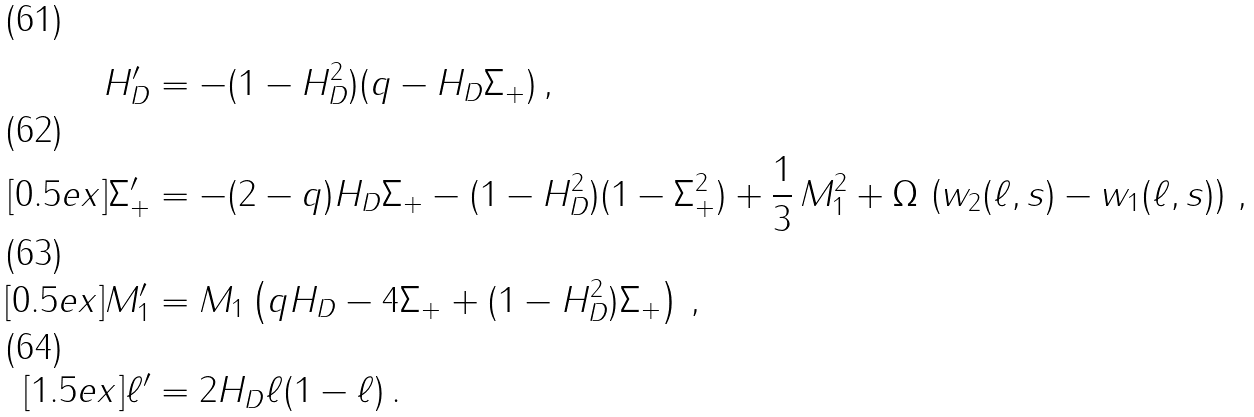<formula> <loc_0><loc_0><loc_500><loc_500>H _ { D } ^ { \prime } & = - ( 1 - H _ { D } ^ { 2 } ) ( q - H _ { D } \Sigma _ { + } ) \, , \\ [ 0 . 5 e x ] \Sigma _ { + } ^ { \prime } & = - ( 2 - q ) H _ { D } \Sigma _ { + } - ( 1 - H _ { D } ^ { 2 } ) ( 1 - \Sigma _ { + } ^ { 2 } ) + \frac { 1 } { 3 } \, M _ { 1 } ^ { 2 } + \Omega \, \left ( w _ { 2 } ( \ell , s ) - w _ { 1 } ( \ell , s ) \right ) \, , \\ [ 0 . 5 e x ] M _ { 1 } ^ { \prime } & = M _ { 1 } \left ( q H _ { D } - 4 \Sigma _ { + } + ( 1 - H _ { D } ^ { 2 } ) \Sigma _ { + } \right ) \, , \\ [ 1 . 5 e x ] \ell ^ { \prime } & = 2 H _ { D } \ell ( 1 - \ell ) \, .</formula> 